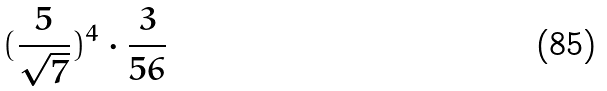<formula> <loc_0><loc_0><loc_500><loc_500>( \frac { 5 } { \sqrt { 7 } } ) ^ { 4 } \cdot \frac { 3 } { 5 6 }</formula> 